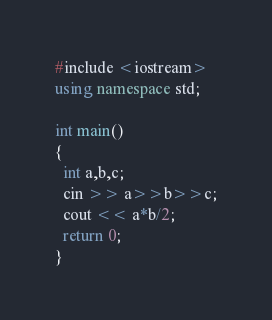<code> <loc_0><loc_0><loc_500><loc_500><_C#_>#include <iostream>
using namespace std;

int main()
{
  int a,b,c;
  cin >> a>>b>>c;
  cout << a*b/2;
  return 0;
}</code> 